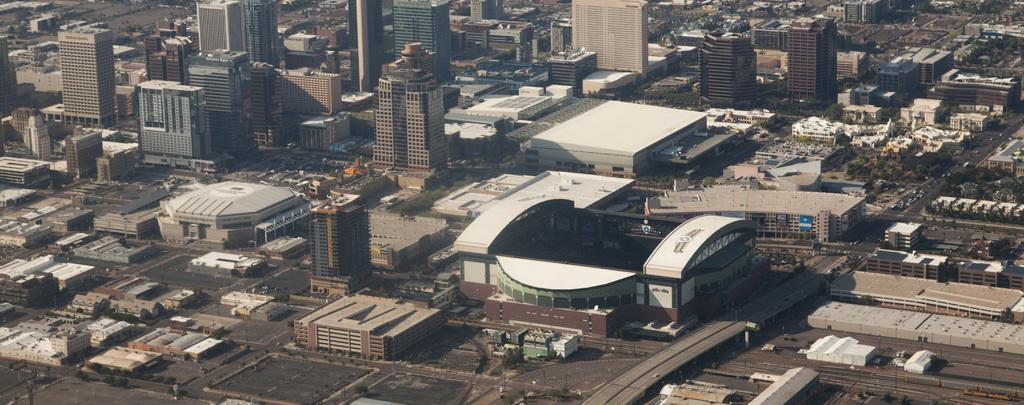What type of location is shown in the image? The image depicts a city. What structures can be seen in the city? There are buildings in the image. Are there any natural elements present in the city? Yes, trees are present in the image. What are the poles used for in the image? The poles are likely used for streetlights or other utilities in the city. How are the roads connected in the image? The roads are connected to each other, allowing vehicles to travel through the city. What types of vehicles can be seen on the roads? Vehicles such as cars and trucks are on the roads in the image. Can you tell me how many animals are in the zoo in the image? There is no zoo present in the image; it depicts a city with buildings, trees, poles, roads, and vehicles. 